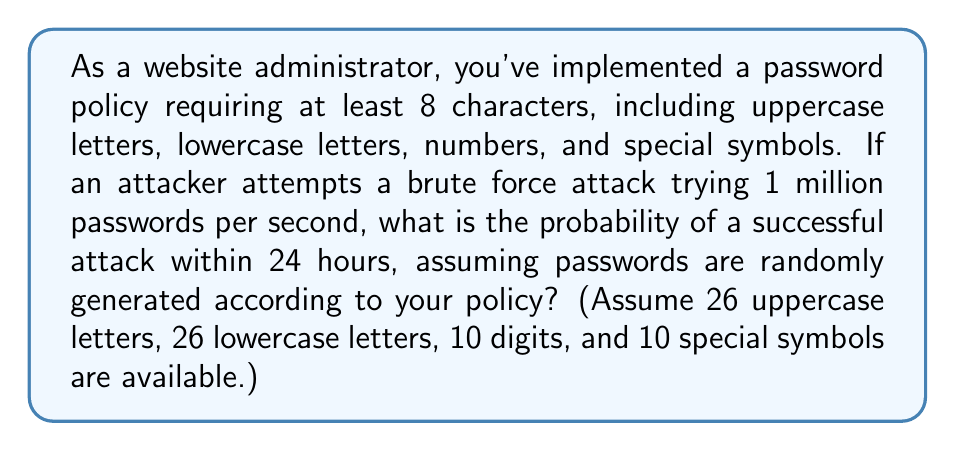What is the answer to this math problem? Let's approach this step-by-step:

1) First, calculate the total number of possible passwords:
   Total characters = 26 (uppercase) + 26 (lowercase) + 10 (digits) + 10 (special) = 72
   Possible combinations = $72^8$ (as the password is at least 8 characters long)

2) Calculate the number of attempts in 24 hours:
   Attempts per second = 1,000,000
   Seconds in 24 hours = 24 * 60 * 60 = 86,400
   Total attempts = 1,000,000 * 86,400 = 86,400,000,000

3) The probability of success is the number of attempts divided by the total number of possible passwords:

   $P(\text{success}) = \frac{\text{Number of attempts}}{\text{Total possible passwords}}$

   $P(\text{success}) = \frac{86,400,000,000}{72^8}$

4) Let's calculate this:
   $72^8 = 722,204,136,308,736$

   $P(\text{success}) = \frac{86,400,000,000}{722,204,136,308,736} \approx 1.196 \times 10^{-4}$

5) Convert to percentage:
   $1.196 \times 10^{-4} * 100\% \approx 0.01196\%$

Therefore, the probability of a successful brute force attack within 24 hours is approximately 0.01196% or about 1 in 8,361.
Answer: $\approx 0.01196\%$ 